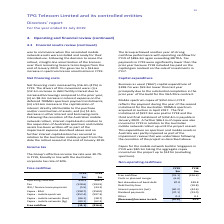According to Tpg Telecom Limited's financial document, Why was there a change in the BAU capital expenditure from FY18 to FY19? Due to the substantial completion in the prior year of the build for the VHA fibre contract.. The document states: "198.7m was $59.3m lower than last year principally due to the substantial completion in the prior year of the build for the VHA fibre contract. Mobile..." Also, Which capital expenditures had increased from FY18 to FY19? The document shows two values: Capex - mobile networks (Aus) and Capex - mobile networks (Sg). From the document: "Capex - mobile networks (Aus) (86.1) (38.7) Capex - mobile networks (Sg) (80.1) (62.3)..." Also, Why was there a change in tax payments from FY18 to FY19? Because FY18 included tax paid on the capital gain realised on the sale of investments in FY17.. The document states: "FY19 were significantly lower than the prior year because FY18 included tax paid on the capital gain realised on the sale of investments in FY17. Capi..." Also, can you calculate: What is the total cost of the Australian 700MHz spectrum? Based on the calculation: 352.4 + 597.3 + 352.4, the result is 1302.1 (in millions). This is based on the information: "Capex - mobile spectrum (352.4) (597.3) Capex - mobile spectrum (352.4) (597.3) Capex - mobile spectrum (352.4) (597.3)..." The key data points involved are: 352.4, 597.3. Also, can you calculate: What is the percentage change of free cashflow from FY18 to FY19? To answer this question, I need to perform calculations using the financial data. The calculation is: (15.1 - 316.6) / 316.6, which equals -95.23 (percentage). This is based on the information: "Free cashflow (15.1) (316.6) Free cashflow (15.1) (316.6)..." The key data points involved are: 15.1, 316.6. Also, can you calculate: How much capital expenditure was incurred on the Singapore project prior to FY19? Based on the calculation: 147 - 80.1, the result is 66.9 (in millions). This is based on the information: "Capex - mobile networks (Sg) (80.1) (62.3) Capex - mobile networks (Sg) (80.1) (62.3) he aggregate capex incurred on the project up to $147m (excluding spectrum). Non-operating cashflows..." The key data points involved are: 147, 80.1. 